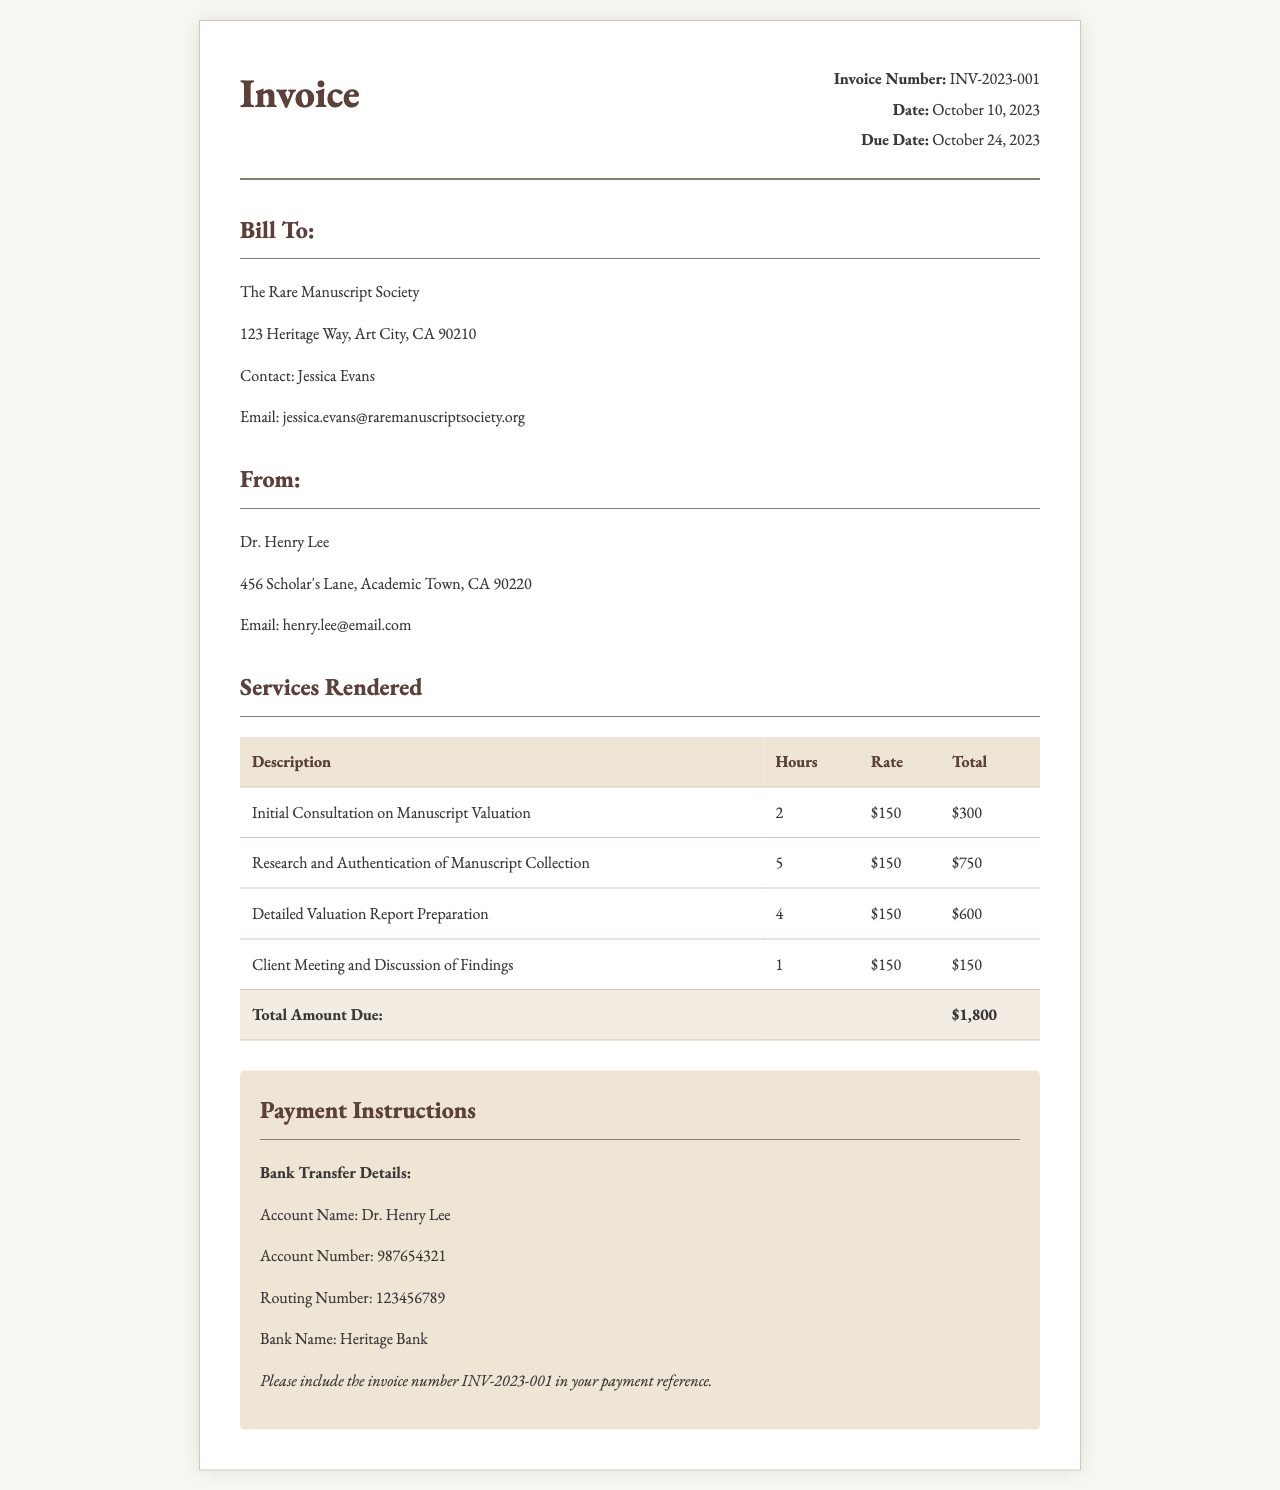What is the invoice number? The invoice number is located in the invoice details section, which specifically identifies this invoice.
Answer: INV-2023-001 Who is the consultant? The consultant's name is found at the top section of the invoice as the one providing the services.
Answer: Dr. Henry Lee What is the total amount due? The total amount due is given in the table summarizing the services rendered where all charges are summed up.
Answer: $1,800 How many hours were spent on the research and authentication of the manuscript collection? This information is stated in the services rendered table under the corresponding service description.
Answer: 5 On what date is payment due? The due date is printed clearly in the invoice details for clarity on when the payment should be made.
Answer: October 24, 2023 What is the rate charged per hour for consulting services? The rate is mentioned in each line item of the services rendered table, which is consistent throughout the invoice.
Answer: $150 How many services are listed in the invoice? The number of services can be counted from the rows in the services rendered table.
Answer: 4 What is the name of the client? The client's name is listed in the bill-to section of the invoice, identifying the organization receiving the services.
Answer: The Rare Manuscript Society What is provided as payment instructions? The payment instructions section includes detailed information for making a bank transfer, which is specific to the transaction.
Answer: Bank Transfer Details 